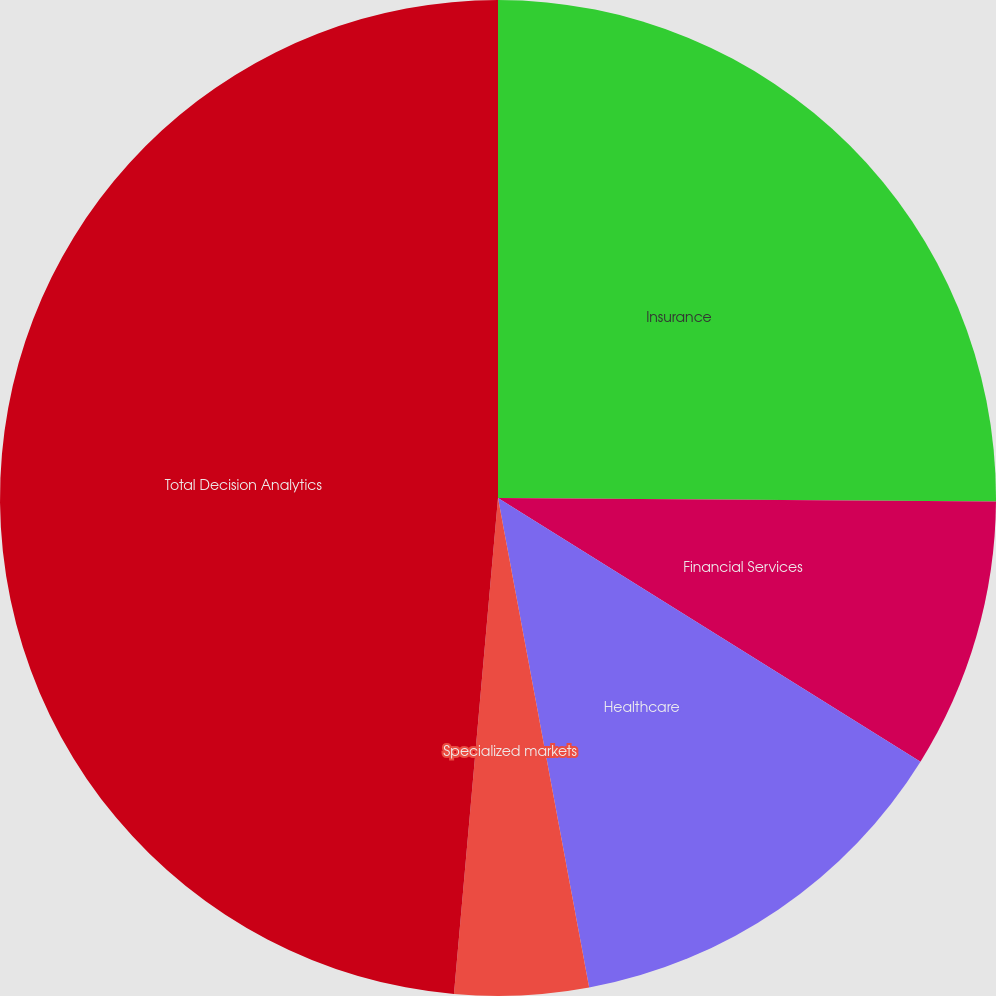Convert chart to OTSL. <chart><loc_0><loc_0><loc_500><loc_500><pie_chart><fcel>Insurance<fcel>Financial Services<fcel>Healthcare<fcel>Specialized markets<fcel>Total Decision Analytics<nl><fcel>25.11%<fcel>8.77%<fcel>13.19%<fcel>4.34%<fcel>48.59%<nl></chart> 